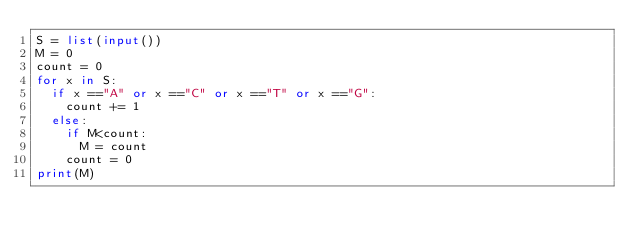<code> <loc_0><loc_0><loc_500><loc_500><_Python_>S = list(input())
M = 0
count = 0
for x in S:
  if x =="A" or x =="C" or x =="T" or x =="G":
    count += 1
  else:
    if M<count:
      M = count
    count = 0
print(M)</code> 